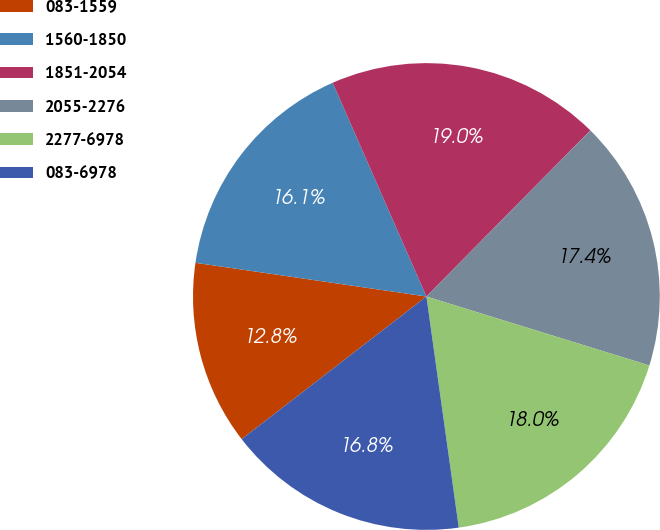<chart> <loc_0><loc_0><loc_500><loc_500><pie_chart><fcel>083-1559<fcel>1560-1850<fcel>1851-2054<fcel>2055-2276<fcel>2277-6978<fcel>083-6978<nl><fcel>12.77%<fcel>16.12%<fcel>18.97%<fcel>17.38%<fcel>18.01%<fcel>16.75%<nl></chart> 